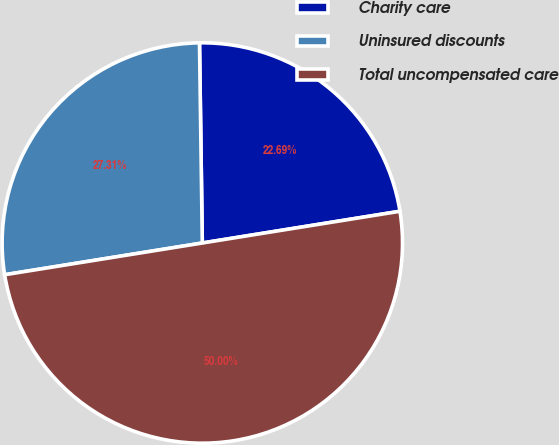<chart> <loc_0><loc_0><loc_500><loc_500><pie_chart><fcel>Charity care<fcel>Uninsured discounts<fcel>Total uncompensated care<nl><fcel>22.69%<fcel>27.31%<fcel>50.0%<nl></chart> 